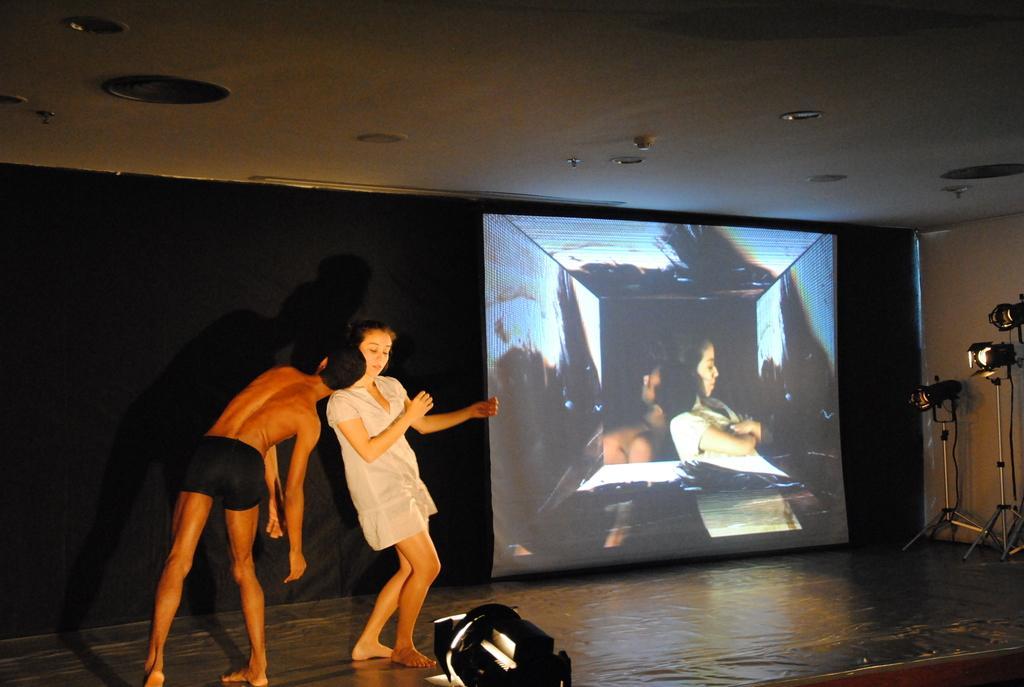How would you summarize this image in a sentence or two? On the left side of the image we can see two people are dancing. In the background of the image we can see the wall, screen, lights, stands and stage. At the top of the image we can see the roof. 